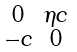<formula> <loc_0><loc_0><loc_500><loc_500>\begin{smallmatrix} 0 & \eta c \\ - c & 0 \end{smallmatrix}</formula> 